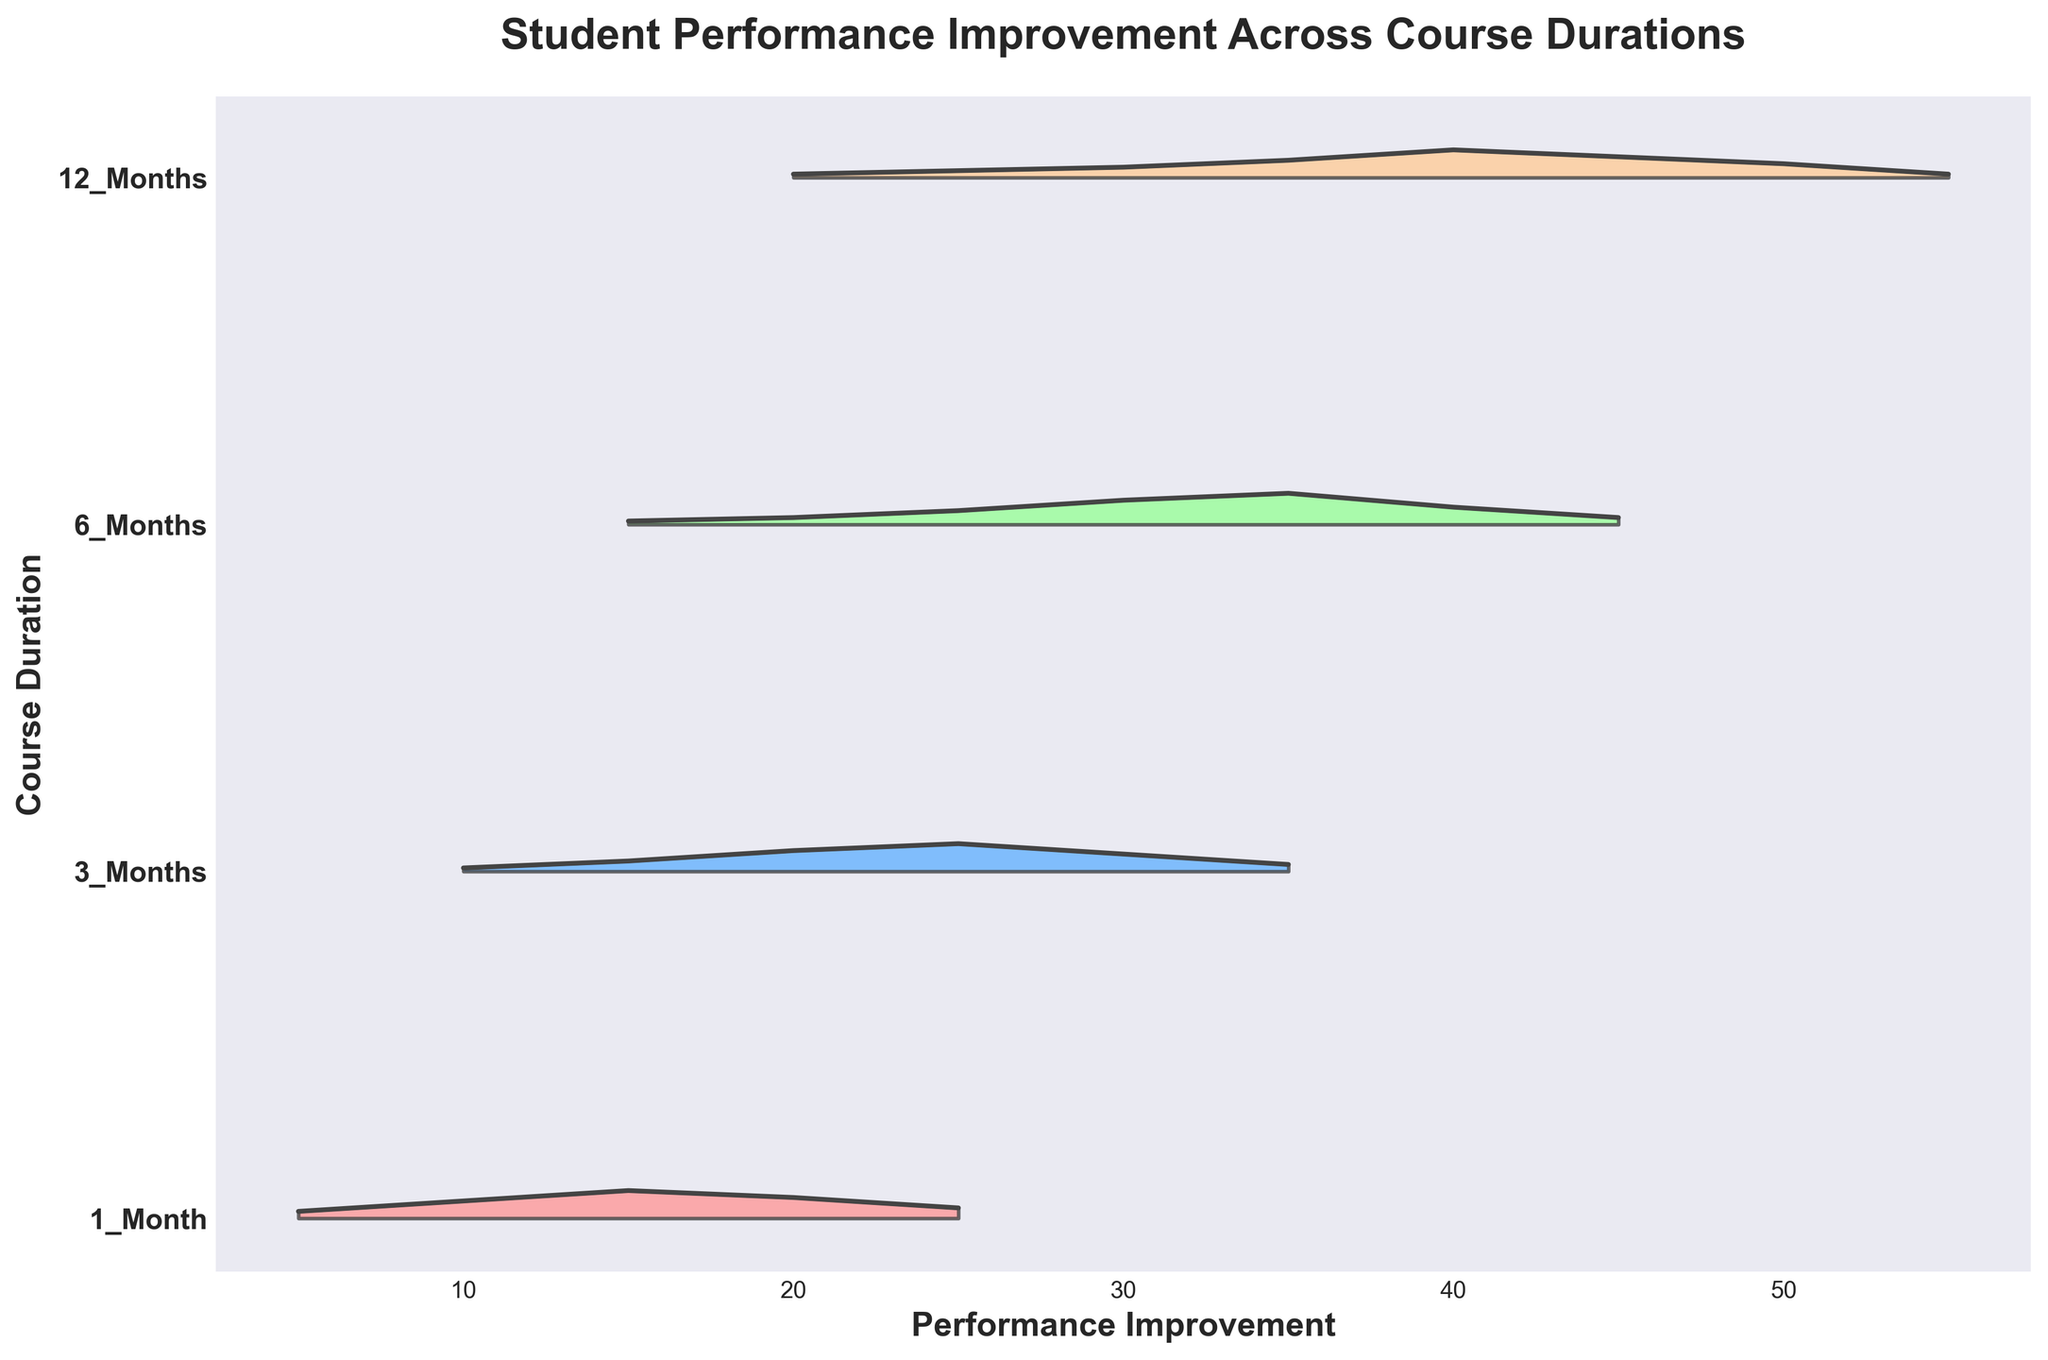What is the title of the ridgeline plot? The title is found at the top of the plot and summarizes the chart's main point.
Answer: Student Performance Improvement Across Course Durations What is depicted on the x-axis and y-axis? The x-axis represents 'Performance Improvement', while the y-axis shows 'Course Duration'. This can be determined by the labels on each axis.
Answer: Performance Improvement and Course Duration Which course duration has the highest density peak in performance improvement? Locate the peak of each density curve and compare their heights. The highest peak is for the 12-month course at a density of 0.08.
Answer: 12 Months Is the performance improvement for 6-Months more variable than for 1-Month? Comparing the span of the curves on the x-axis for both 6-Month and 1-Month courses shows that the 6-Month course has a much wider range (15 to 45) compared to the 1-Month course (5 to 25), indicating more variability.
Answer: Yes Which course duration shows the highest improvement (maximum value) in speaking skills? Locate the farthest right point of each density curve. The 12-month course reaches the highest value of 55.
Answer: 12 Months What is the performance improvement for the 3-Months course at the highest density? The highest density point for the 3-Months course curve is at a density of 0.08, which corresponds to a performance improvement of 25.
Answer: 25 Compare the maximum performance improvement values between the shortest and longest course durations represented. The maximum improvement for the shortest (1-Month) is 25, and for the longest (12-Months), it is 55.
Answer: 1 Month: 25, 12 Months: 55 How does the performance improvement compare between the 6-Months and 12-Months courses at a density level of 0.02? For the 6-Months course, the performance improvement is at 20 and 45, whereas for the 12-Months course, it is 25.
Answer: 6 Months: 20 and 45, 12 Months: 25 What trend can you observe for the performance improvements as the course duration increases? Observing the positions and spans of the density curves, it can be noted that longer courses tend to achieve higher levels of performance improvement. The peaks and spans shift to the right as duration increases.
Answer: Longer courses lead to higher performance improvements 